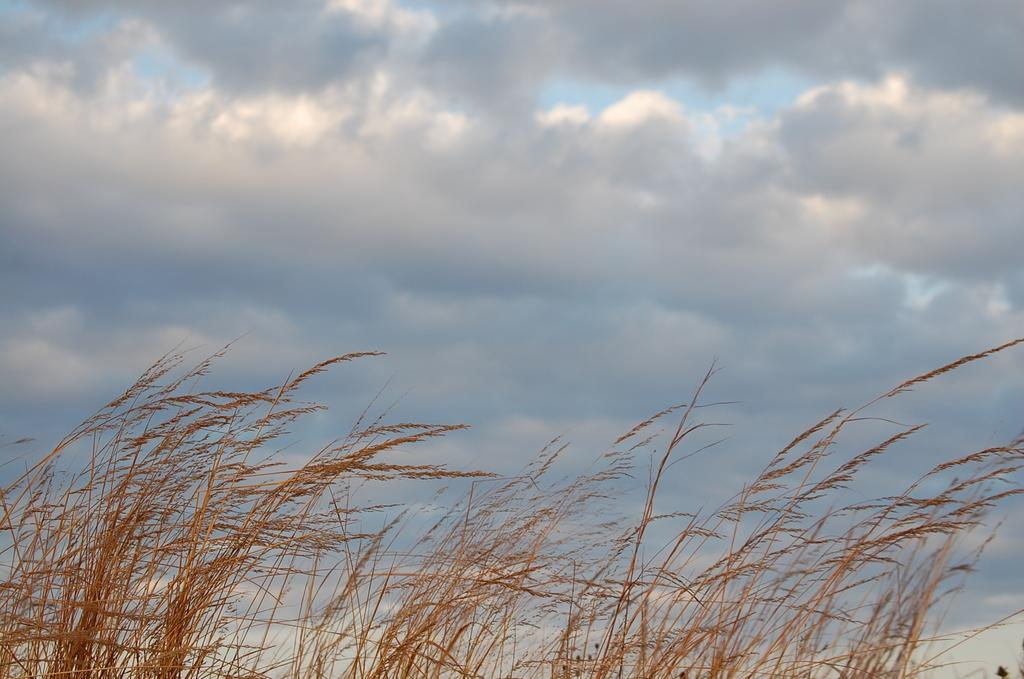What type of vegetation can be seen in the image? There is grass in the image. What part of the natural environment is visible in the image? The sky is visible in the image. What can be observed in the sky? Clouds are present in the sky. What tax is being discussed by the committee in the image? There is no committee or tax present in the image; it features grass and clouds in the sky. How many sticks are visible in the image? There are no sticks visible in the image. 